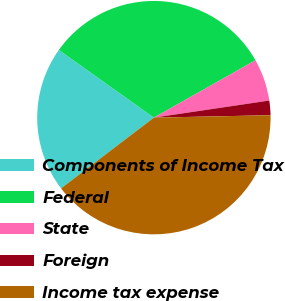<chart> <loc_0><loc_0><loc_500><loc_500><pie_chart><fcel>Components of Income Tax<fcel>Federal<fcel>State<fcel>Foreign<fcel>Income tax expense<nl><fcel>20.22%<fcel>31.97%<fcel>5.84%<fcel>2.01%<fcel>39.97%<nl></chart> 